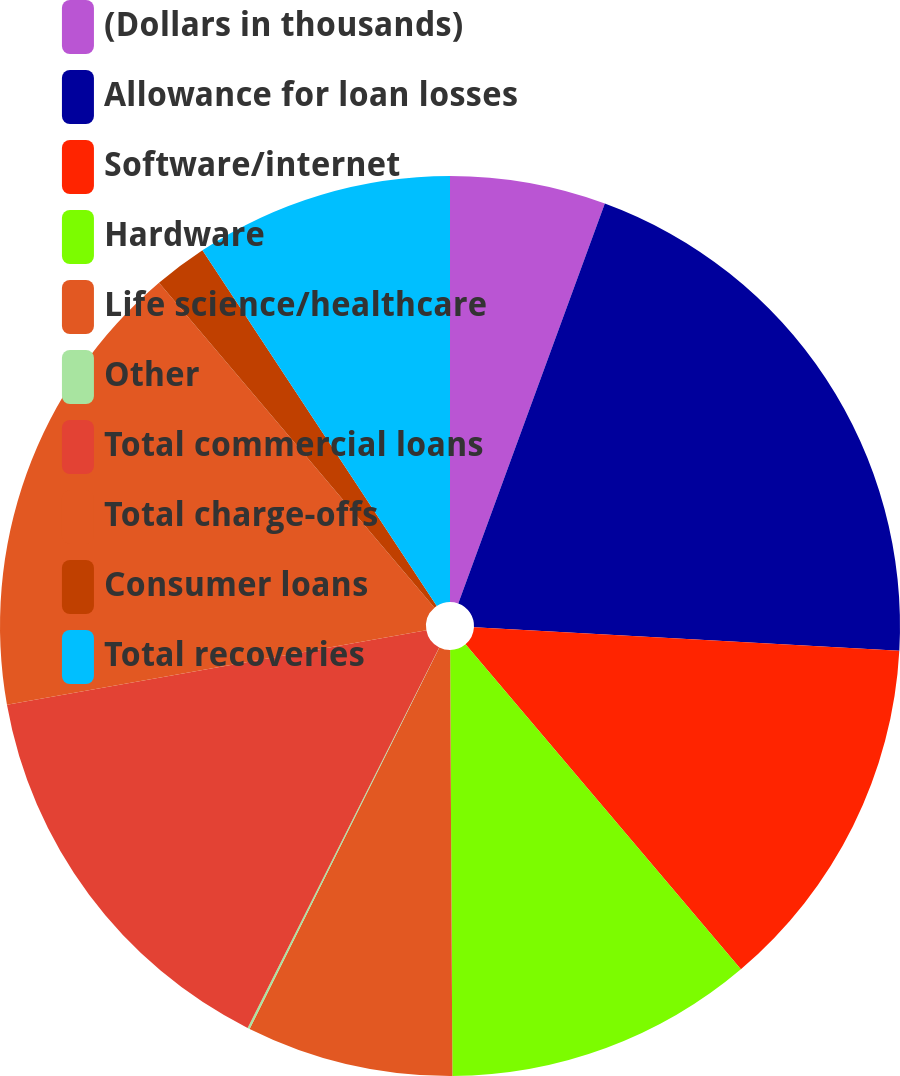<chart> <loc_0><loc_0><loc_500><loc_500><pie_chart><fcel>(Dollars in thousands)<fcel>Allowance for loan losses<fcel>Software/internet<fcel>Hardware<fcel>Life science/healthcare<fcel>Other<fcel>Total commercial loans<fcel>Total charge-offs<fcel>Consumer loans<fcel>Total recoveries<nl><fcel>5.59%<fcel>20.28%<fcel>12.94%<fcel>11.1%<fcel>7.43%<fcel>0.08%<fcel>14.77%<fcel>16.61%<fcel>1.92%<fcel>9.27%<nl></chart> 